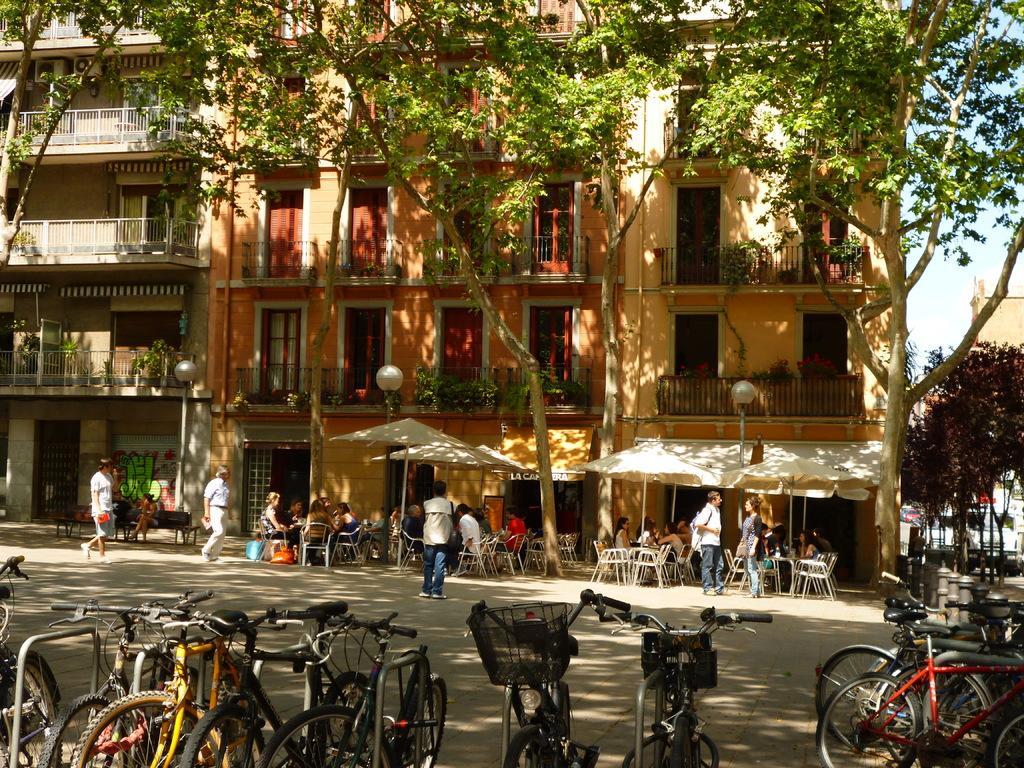Can you describe this image briefly? In this image in the center there are buildings and trees, and also there are some tents, chairs, tables, and some persons are sitting and some persons are standing and some of them are walking. At the bottom there are some cycles, and also on the right side there are some trees and buildings. At the bottom there is a walkway. 